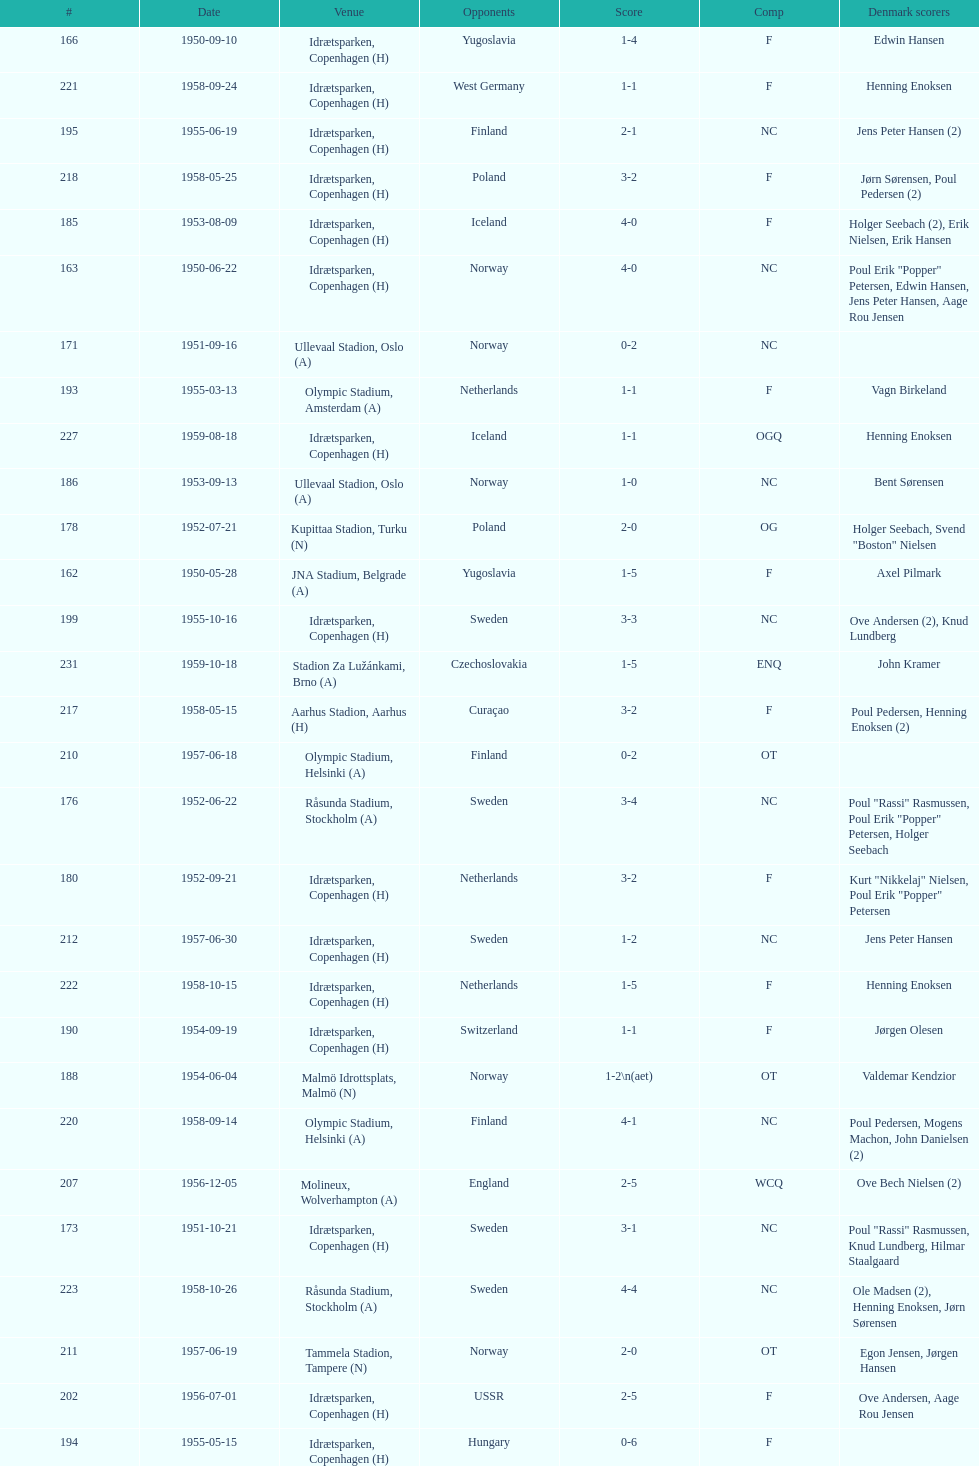Who did they play in the game listed directly above july 25, 1952? Poland. 